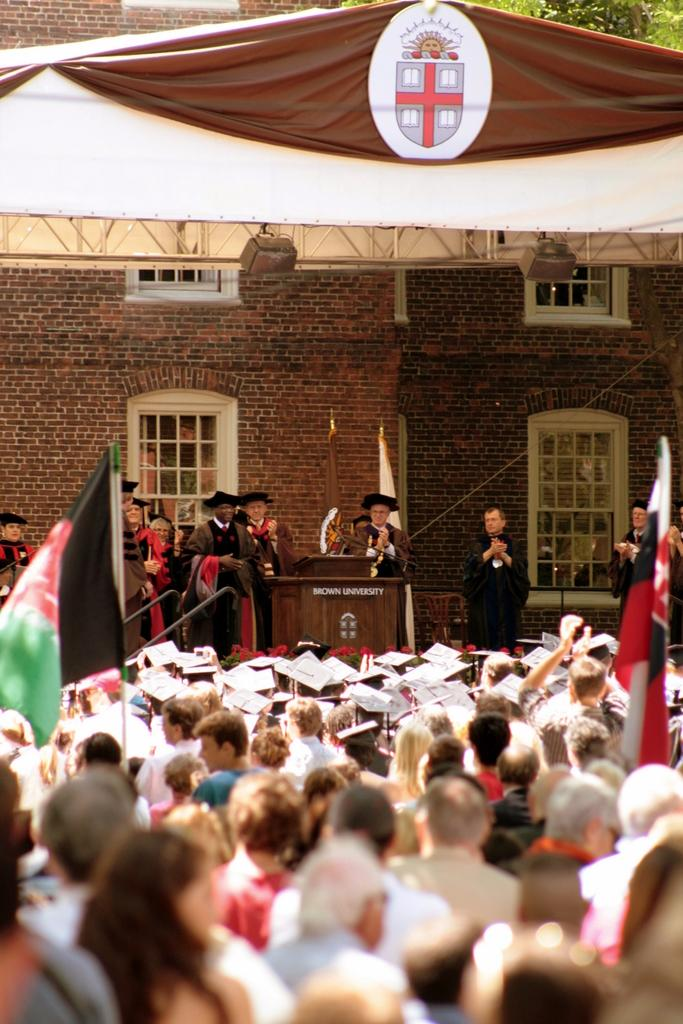How many people are in the image? There is a group of people in the image, but the exact number is not specified. What are some of the people in the image doing? Some of the people are standing. What object can be seen in the image that might be used for speaking or presenting? There is a podium in the image. What can be seen in the background of the image that represents a country or organization? There are flags in the image. What type of structure is visible in the background of the image? There is a building with windows in the background. What type of natural element can be seen in the background of the image? There is a tree visible in the background. What type of corn is being grown in the image? There is no corn present in the image. 